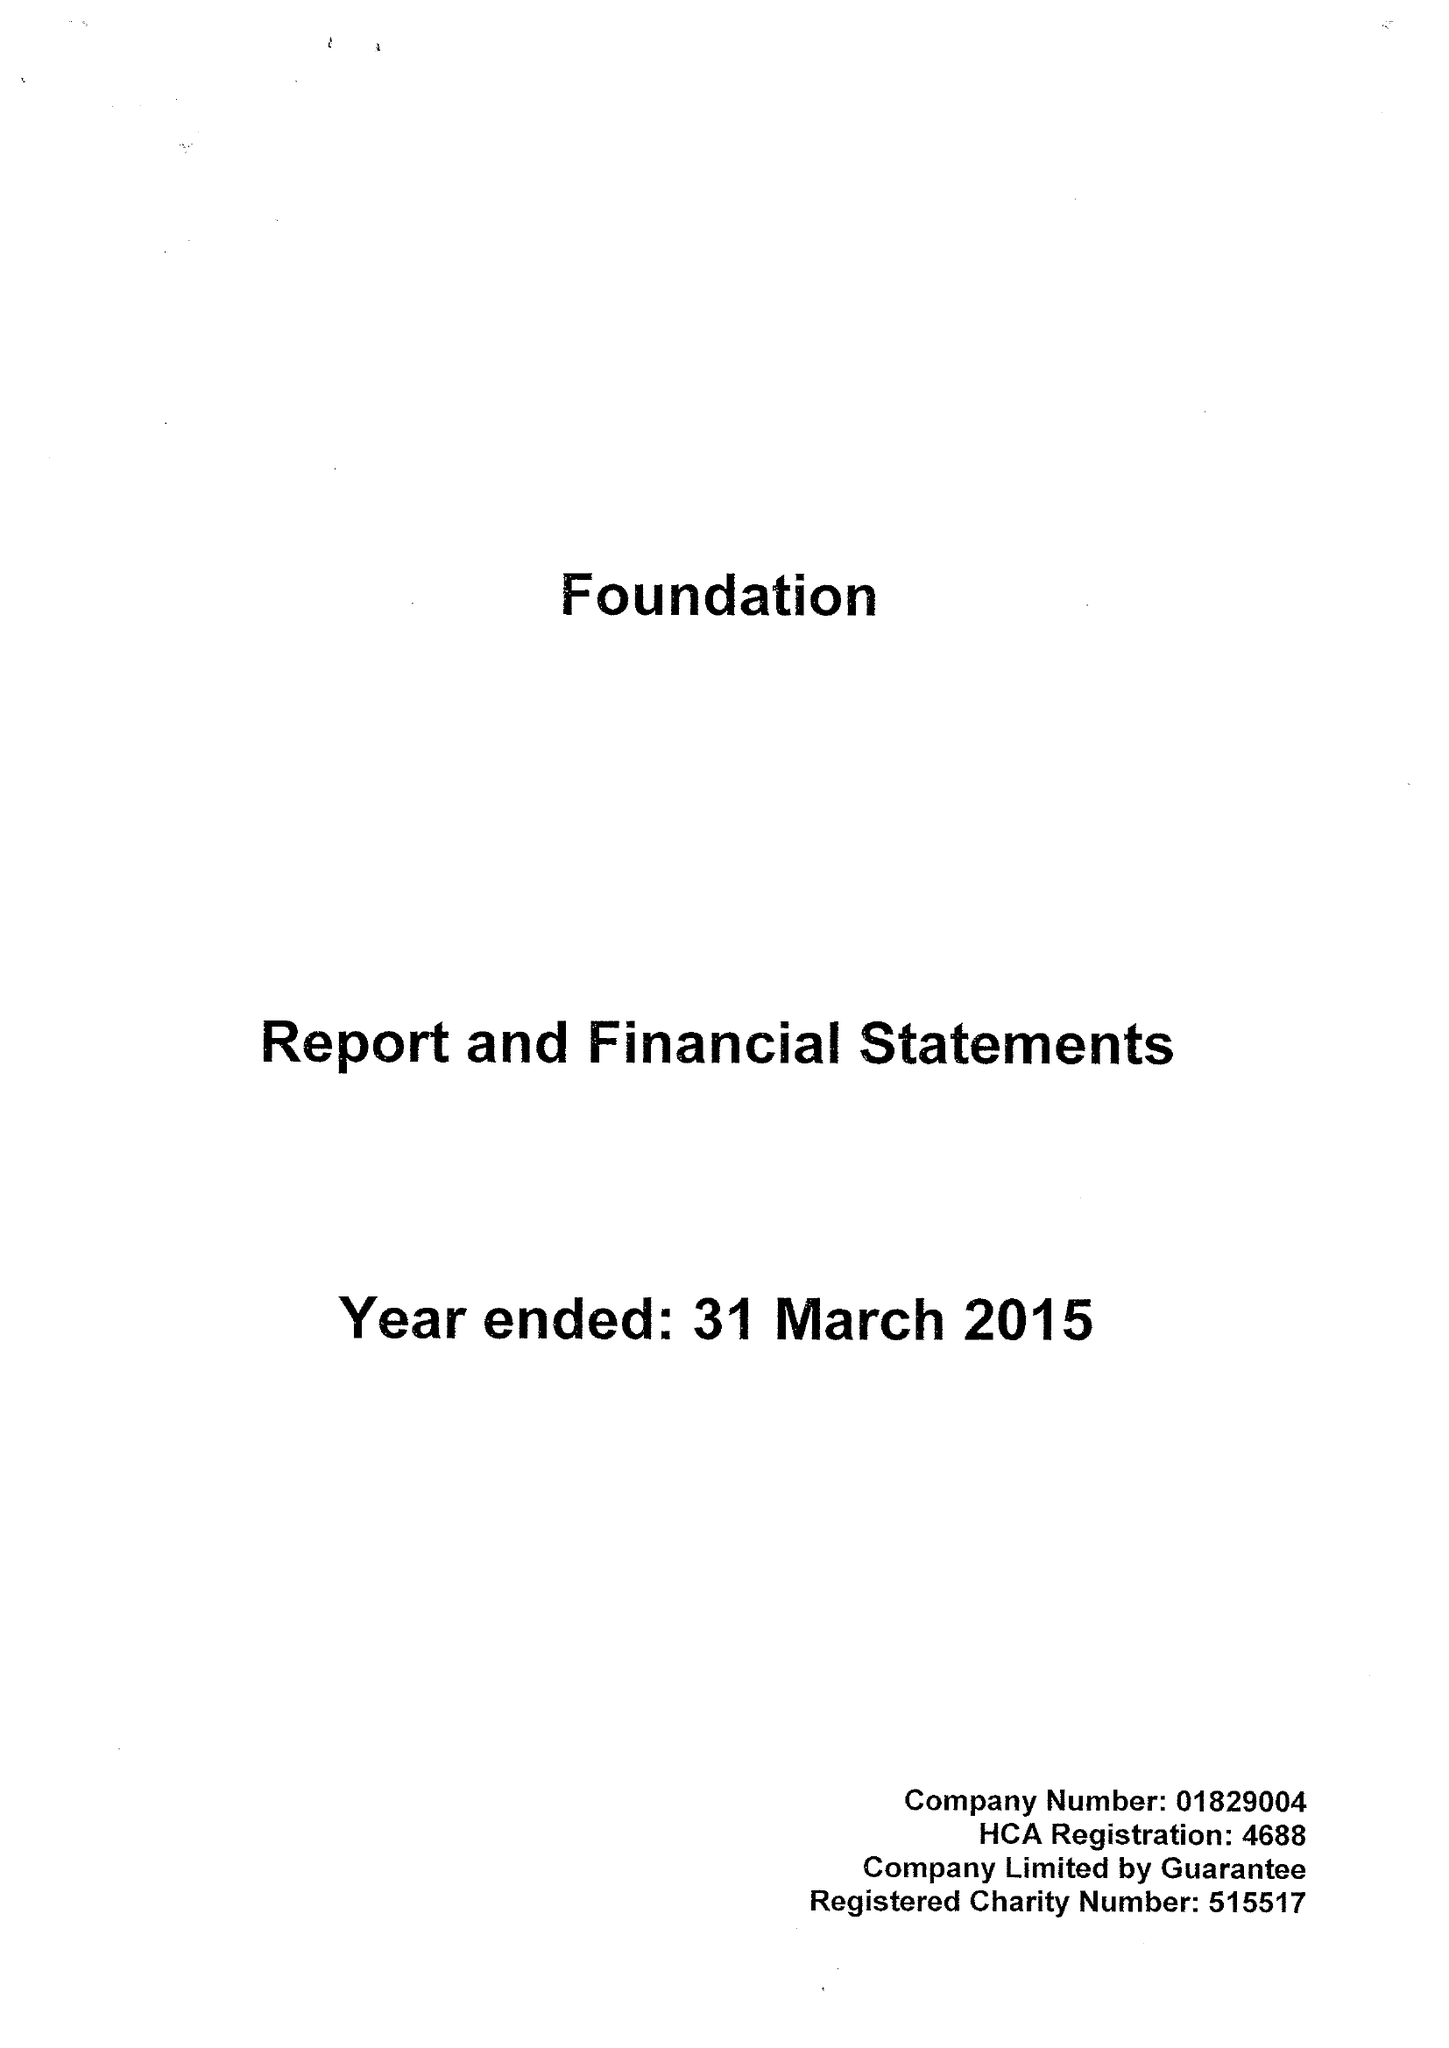What is the value for the address__street_line?
Answer the question using a single word or phrase. SEACROFT 